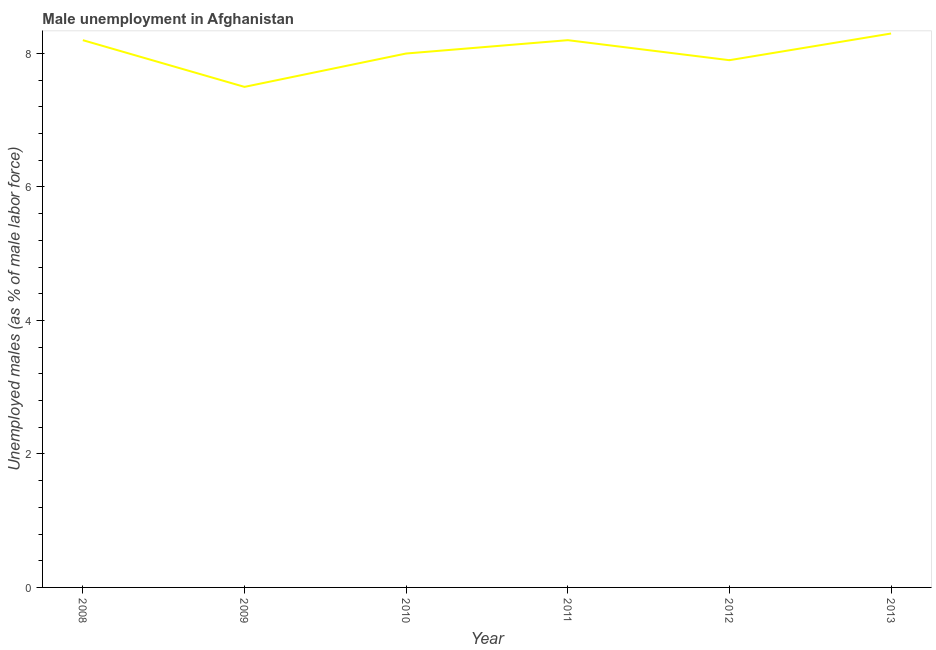What is the unemployed males population in 2010?
Provide a succinct answer. 8. Across all years, what is the maximum unemployed males population?
Provide a short and direct response. 8.3. What is the sum of the unemployed males population?
Make the answer very short. 48.1. What is the difference between the unemployed males population in 2008 and 2012?
Offer a very short reply. 0.3. What is the average unemployed males population per year?
Your answer should be compact. 8.02. What is the median unemployed males population?
Provide a short and direct response. 8.1. In how many years, is the unemployed males population greater than 4.8 %?
Offer a very short reply. 6. Do a majority of the years between 2011 and 2008 (inclusive) have unemployed males population greater than 4.4 %?
Offer a terse response. Yes. What is the ratio of the unemployed males population in 2009 to that in 2013?
Your answer should be very brief. 0.9. What is the difference between the highest and the second highest unemployed males population?
Ensure brevity in your answer.  0.1. What is the difference between the highest and the lowest unemployed males population?
Provide a succinct answer. 0.8. In how many years, is the unemployed males population greater than the average unemployed males population taken over all years?
Offer a terse response. 3. How many lines are there?
Offer a very short reply. 1. Are the values on the major ticks of Y-axis written in scientific E-notation?
Give a very brief answer. No. What is the title of the graph?
Offer a terse response. Male unemployment in Afghanistan. What is the label or title of the X-axis?
Give a very brief answer. Year. What is the label or title of the Y-axis?
Ensure brevity in your answer.  Unemployed males (as % of male labor force). What is the Unemployed males (as % of male labor force) in 2008?
Make the answer very short. 8.2. What is the Unemployed males (as % of male labor force) in 2011?
Your answer should be very brief. 8.2. What is the Unemployed males (as % of male labor force) of 2012?
Provide a short and direct response. 7.9. What is the Unemployed males (as % of male labor force) of 2013?
Keep it short and to the point. 8.3. What is the difference between the Unemployed males (as % of male labor force) in 2008 and 2009?
Ensure brevity in your answer.  0.7. What is the difference between the Unemployed males (as % of male labor force) in 2008 and 2010?
Make the answer very short. 0.2. What is the difference between the Unemployed males (as % of male labor force) in 2008 and 2011?
Give a very brief answer. 0. What is the difference between the Unemployed males (as % of male labor force) in 2008 and 2013?
Your answer should be very brief. -0.1. What is the difference between the Unemployed males (as % of male labor force) in 2009 and 2011?
Ensure brevity in your answer.  -0.7. What is the difference between the Unemployed males (as % of male labor force) in 2009 and 2012?
Your response must be concise. -0.4. What is the difference between the Unemployed males (as % of male labor force) in 2010 and 2012?
Your answer should be very brief. 0.1. What is the difference between the Unemployed males (as % of male labor force) in 2011 and 2012?
Keep it short and to the point. 0.3. What is the difference between the Unemployed males (as % of male labor force) in 2011 and 2013?
Offer a terse response. -0.1. What is the ratio of the Unemployed males (as % of male labor force) in 2008 to that in 2009?
Your response must be concise. 1.09. What is the ratio of the Unemployed males (as % of male labor force) in 2008 to that in 2010?
Your answer should be compact. 1.02. What is the ratio of the Unemployed males (as % of male labor force) in 2008 to that in 2011?
Your answer should be compact. 1. What is the ratio of the Unemployed males (as % of male labor force) in 2008 to that in 2012?
Ensure brevity in your answer.  1.04. What is the ratio of the Unemployed males (as % of male labor force) in 2008 to that in 2013?
Ensure brevity in your answer.  0.99. What is the ratio of the Unemployed males (as % of male labor force) in 2009 to that in 2010?
Provide a succinct answer. 0.94. What is the ratio of the Unemployed males (as % of male labor force) in 2009 to that in 2011?
Make the answer very short. 0.92. What is the ratio of the Unemployed males (as % of male labor force) in 2009 to that in 2012?
Your response must be concise. 0.95. What is the ratio of the Unemployed males (as % of male labor force) in 2009 to that in 2013?
Your answer should be compact. 0.9. What is the ratio of the Unemployed males (as % of male labor force) in 2010 to that in 2011?
Your answer should be very brief. 0.98. What is the ratio of the Unemployed males (as % of male labor force) in 2010 to that in 2013?
Ensure brevity in your answer.  0.96. What is the ratio of the Unemployed males (as % of male labor force) in 2011 to that in 2012?
Offer a terse response. 1.04. What is the ratio of the Unemployed males (as % of male labor force) in 2011 to that in 2013?
Your response must be concise. 0.99. 